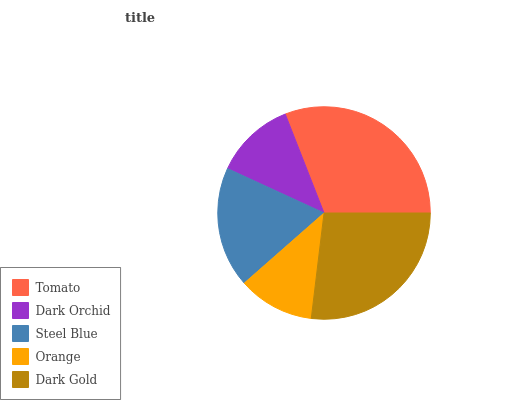Is Orange the minimum?
Answer yes or no. Yes. Is Tomato the maximum?
Answer yes or no. Yes. Is Dark Orchid the minimum?
Answer yes or no. No. Is Dark Orchid the maximum?
Answer yes or no. No. Is Tomato greater than Dark Orchid?
Answer yes or no. Yes. Is Dark Orchid less than Tomato?
Answer yes or no. Yes. Is Dark Orchid greater than Tomato?
Answer yes or no. No. Is Tomato less than Dark Orchid?
Answer yes or no. No. Is Steel Blue the high median?
Answer yes or no. Yes. Is Steel Blue the low median?
Answer yes or no. Yes. Is Orange the high median?
Answer yes or no. No. Is Dark Gold the low median?
Answer yes or no. No. 